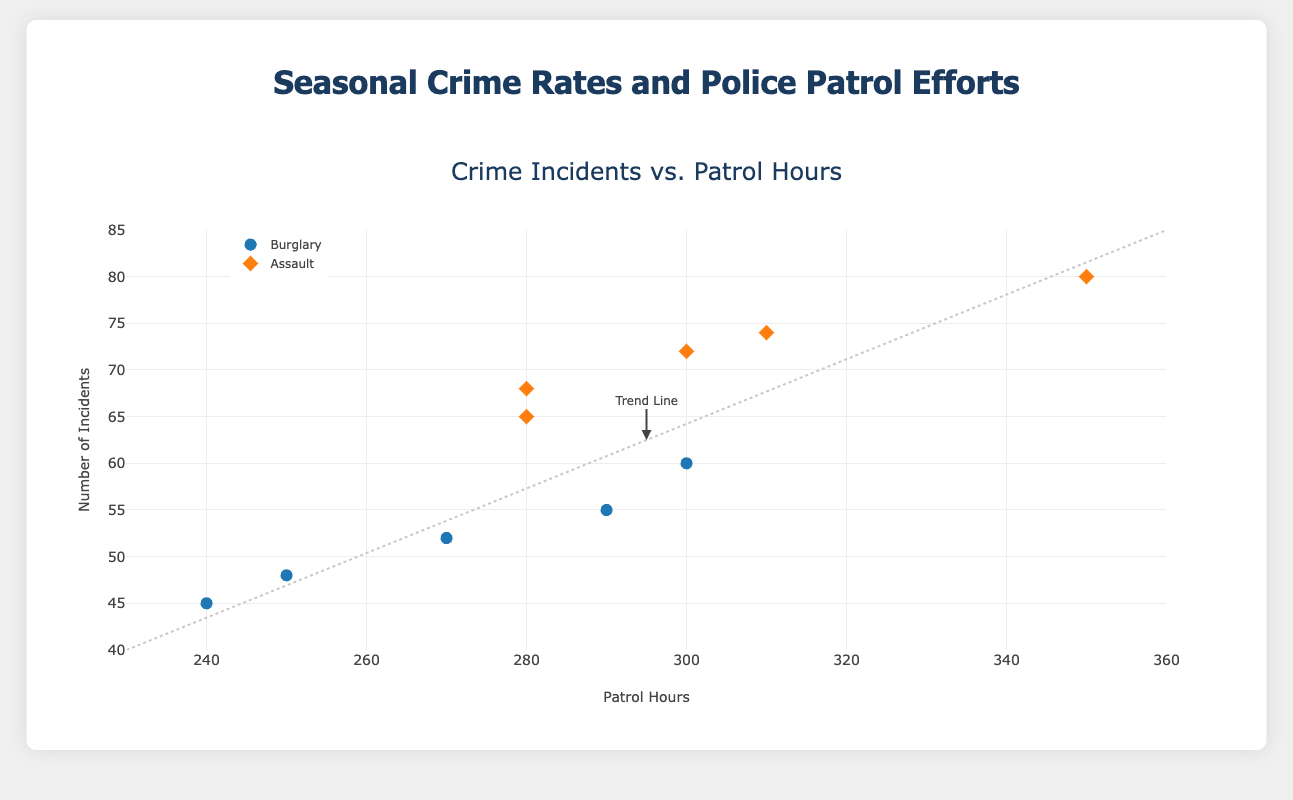What is the title of the plot? The title of the plot is displayed at the top, which reads "Crime Incidents vs. Patrol Hours".
Answer: Crime Incidents vs. Patrol Hours What do the x-axis and y-axis represent? The labels of the axes are provided on the plot. The x-axis represents "Patrol Hours" and the y-axis represents "Number of Incidents".
Answer: x-axis: Patrol Hours, y-axis: Number of Incidents How many data points are there for Burglary? The data points for Burglary are represented by blue circles. By counting them, we see there are 5 data points.
Answer: 5 Which crime type had higher incidents in July? The plot uses shapes and colors to distinguish crime types. In July, Assault data is represented by orange diamonds and shows 80 incidents, while Burglary (blue circles) shows 60 incidents.
Answer: Assault What is the range of the x-axis (Patrol Hours)? Observing the x-axis, it is marked from 230 to 360. These markers indicate the boundaries of the range.
Answer: 230 to 360 Which month corresponds to the highest patrol hours for Assault? Hovering over the orange diamonds and reading tooltips shows the highest patrol hours are 350 in July for Assault.
Answer: July Calculate the average number of incidents for Burglary across all months. The incidents for Burglary are: 48, 52, 60, 55, 45. The average is calculated as (48 + 52 + 60 + 55 + 45) / 5 = 260 / 5 = 52.
Answer: 52 Compare the number of incidents for Burglary in January and April. Which month had more incidents? Referring to the blue circles labeled with their respective months: January shows 48 incidents, and April shows 52 incidents.
Answer: April Identify the month with the lowest number of incidents for Assault. By examining the orange diamonds and their labels, the lowest number of incidents for Assault occurs in April with 65 incidents.
Answer: April Is there a trend indicating more patrol hours lead to fewer incidents? The plot includes a trend line that generally shows a negative slope, indicating an inverse relationship between patrol hours and the number of incidents.
Answer: Yes 